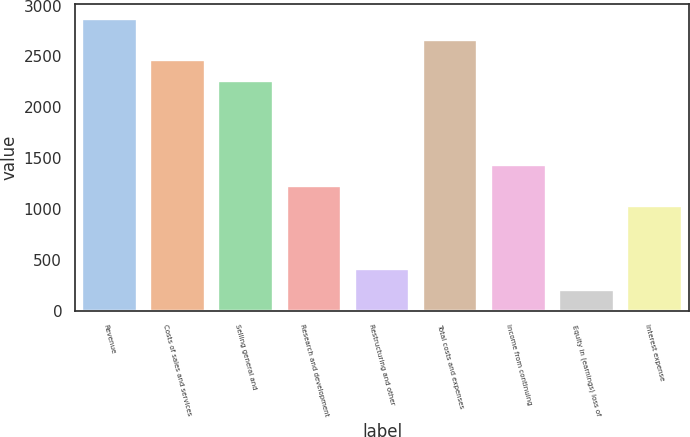<chart> <loc_0><loc_0><loc_500><loc_500><bar_chart><fcel>Revenue<fcel>Costs of sales and services<fcel>Selling general and<fcel>Research and development<fcel>Restructuring and other<fcel>Total costs and expenses<fcel>Income from continuing<fcel>Equity in (earnings) loss of<fcel>Interest expense<nl><fcel>2871.54<fcel>2461.38<fcel>2256.3<fcel>1230.9<fcel>410.58<fcel>2666.46<fcel>1435.98<fcel>205.5<fcel>1025.82<nl></chart> 